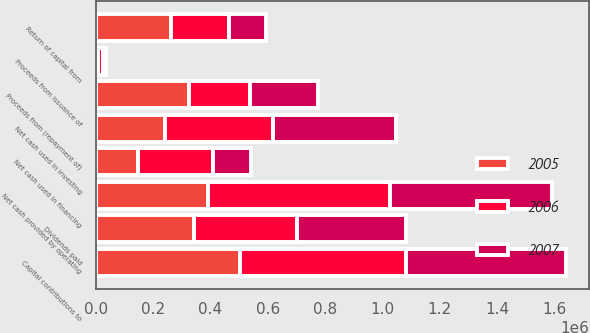Convert chart. <chart><loc_0><loc_0><loc_500><loc_500><stacked_bar_chart><ecel><fcel>Net cash provided by operating<fcel>Return of capital from<fcel>Capital contributions to<fcel>Net cash used in investing<fcel>Proceeds from (repayment of)<fcel>Proceeds from issuance of<fcel>Dividends paid<fcel>Net cash used in financing<nl><fcel>2007<fcel>566688<fcel>129551<fcel>559266<fcel>429715<fcel>238877<fcel>10539<fcel>378892<fcel>134335<nl><fcel>2006<fcel>634128<fcel>201185<fcel>576600<fcel>375415<fcel>211716<fcel>16275<fcel>358746<fcel>259357<nl><fcel>2005<fcel>391776<fcel>262378<fcel>504402<fcel>242024<fcel>325516<fcel>9085<fcel>343092<fcel>148667<nl></chart> 